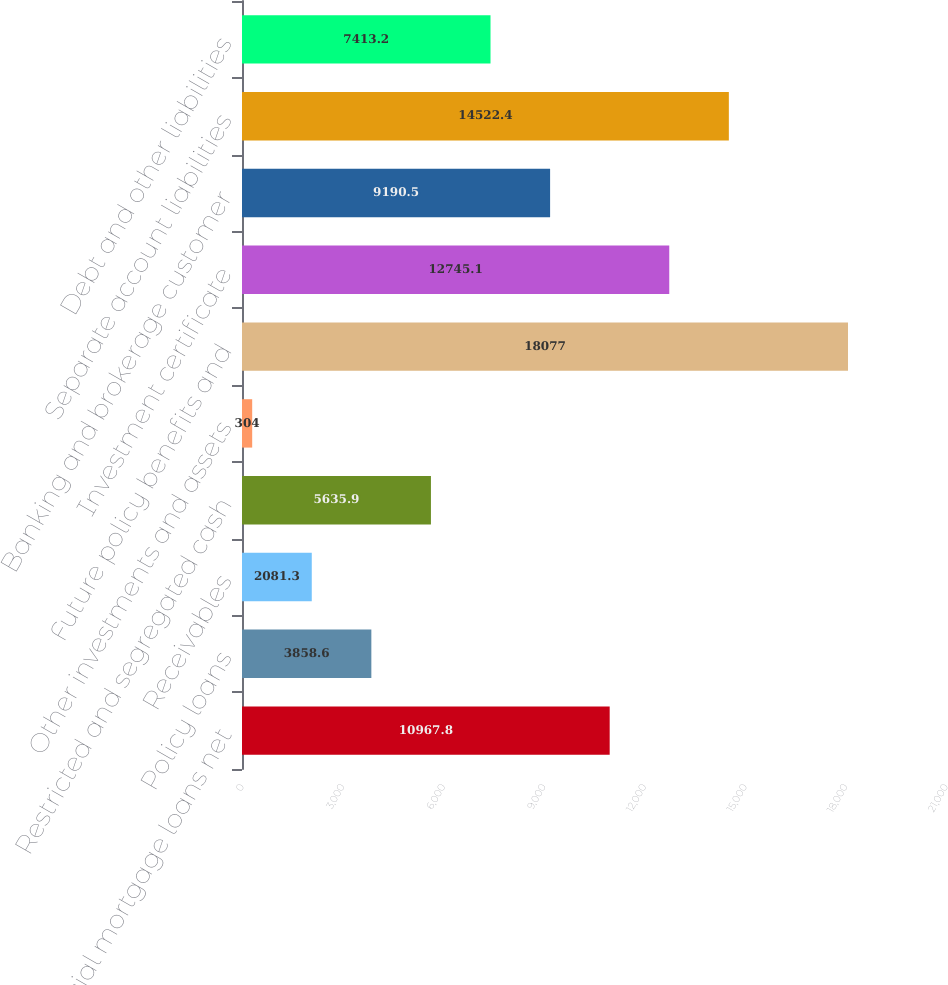Convert chart. <chart><loc_0><loc_0><loc_500><loc_500><bar_chart><fcel>Commercial mortgage loans net<fcel>Policy loans<fcel>Receivables<fcel>Restricted and segregated cash<fcel>Other investments and assets<fcel>Future policy benefits and<fcel>Investment certificate<fcel>Banking and brokerage customer<fcel>Separate account liabilities<fcel>Debt and other liabilities<nl><fcel>10967.8<fcel>3858.6<fcel>2081.3<fcel>5635.9<fcel>304<fcel>18077<fcel>12745.1<fcel>9190.5<fcel>14522.4<fcel>7413.2<nl></chart> 